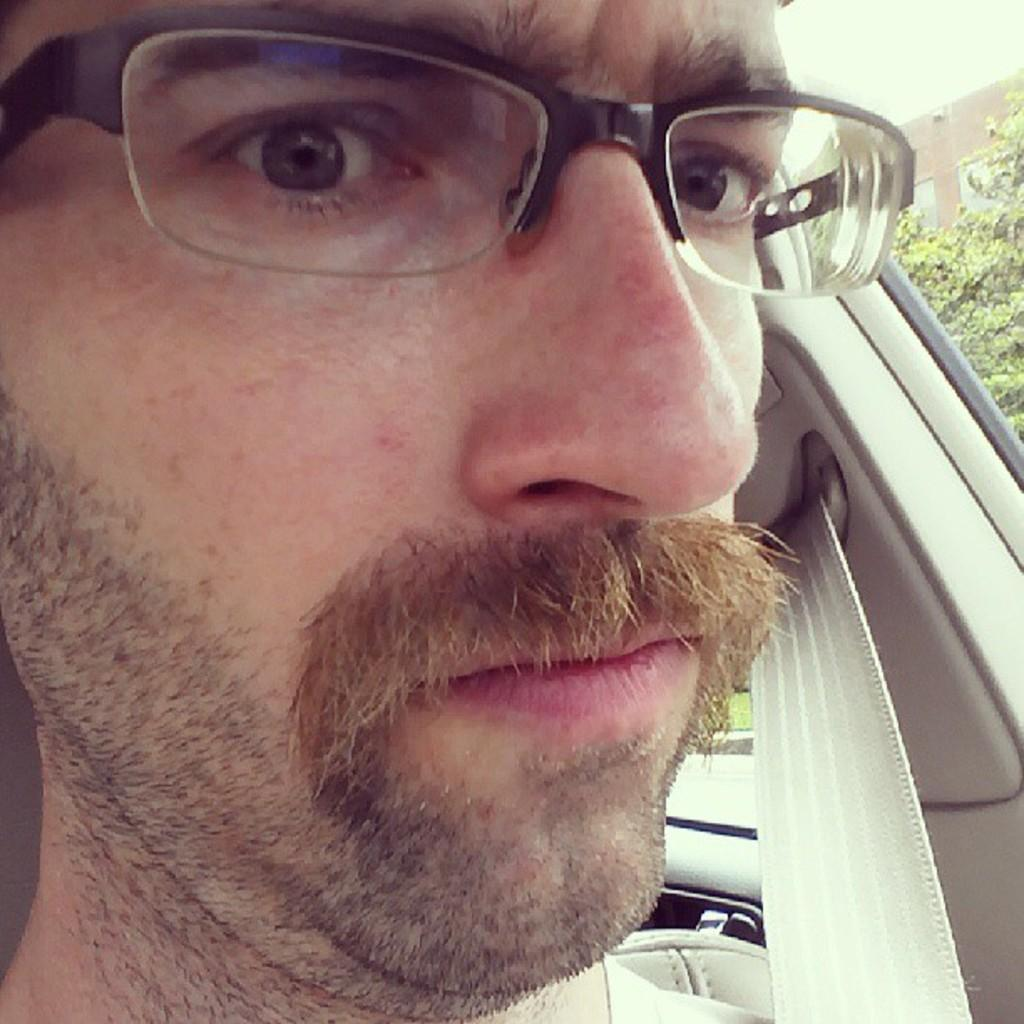Who is present in the image? There is a person in the image. What can be observed about the person's appearance? The person is wearing spectacles. Where is the person located in the image? The person is sitting in a car. What can be seen through the car window? Trees, a building, and the sky are visible through the car window. What type of voice can be heard coming from the stage in the image? There is no stage present in the image, so it's not possible to determine what type of voice might be heard. 